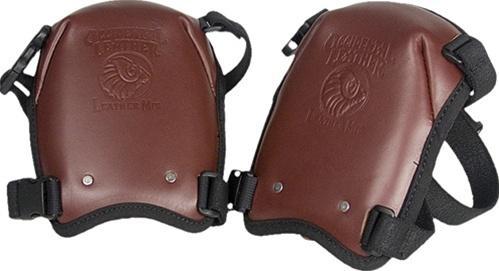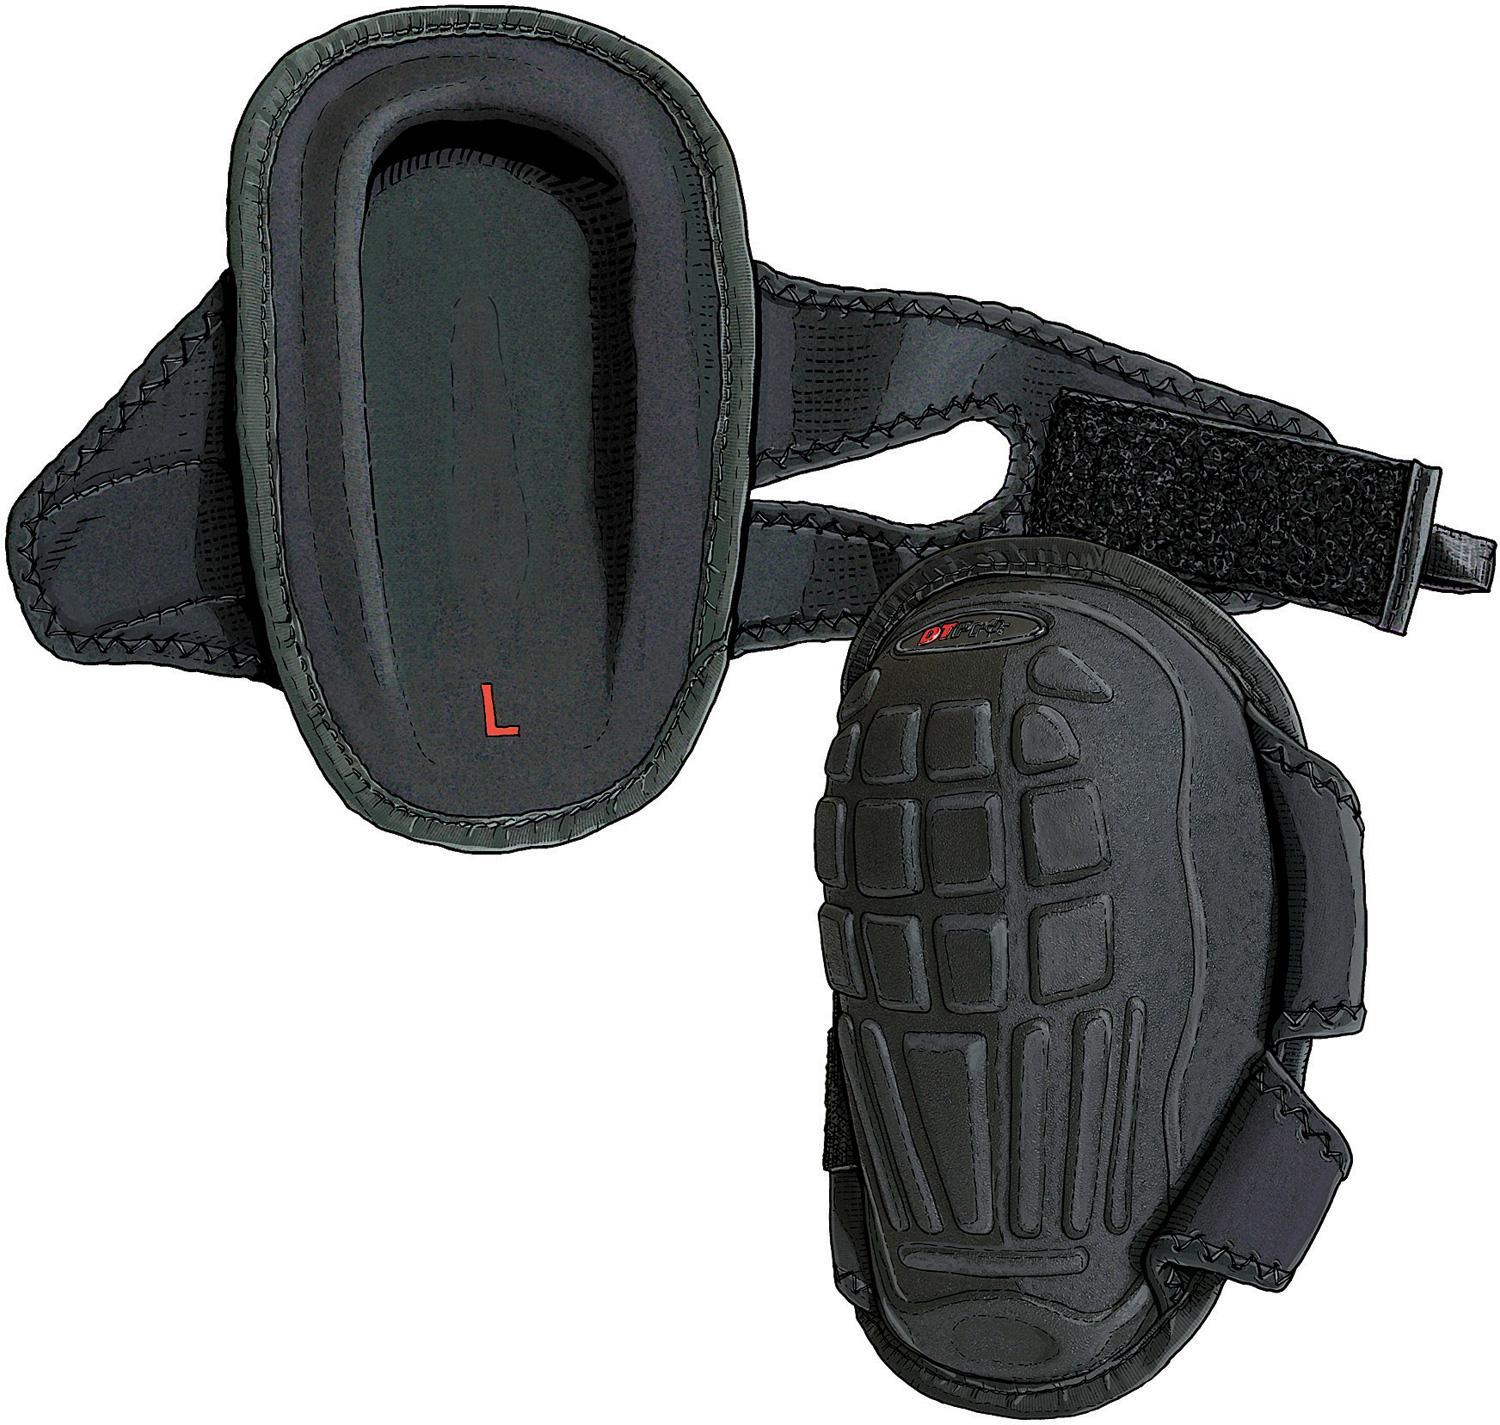The first image is the image on the left, the second image is the image on the right. Analyze the images presented: Is the assertion "The front and back side of one of the pads is visible." valid? Answer yes or no. Yes. 